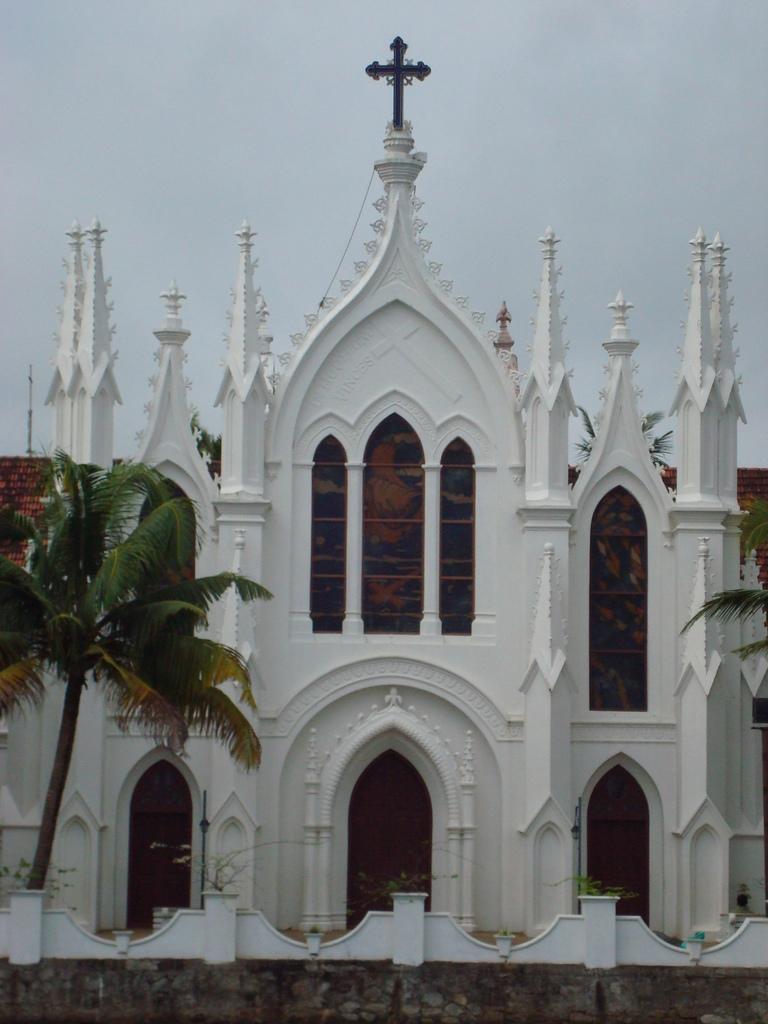Can you describe this image briefly? In this image we can see a church, at the top we can see a cross symbol, in front of the church we can see plants and trees, in the background we can see the sky. 